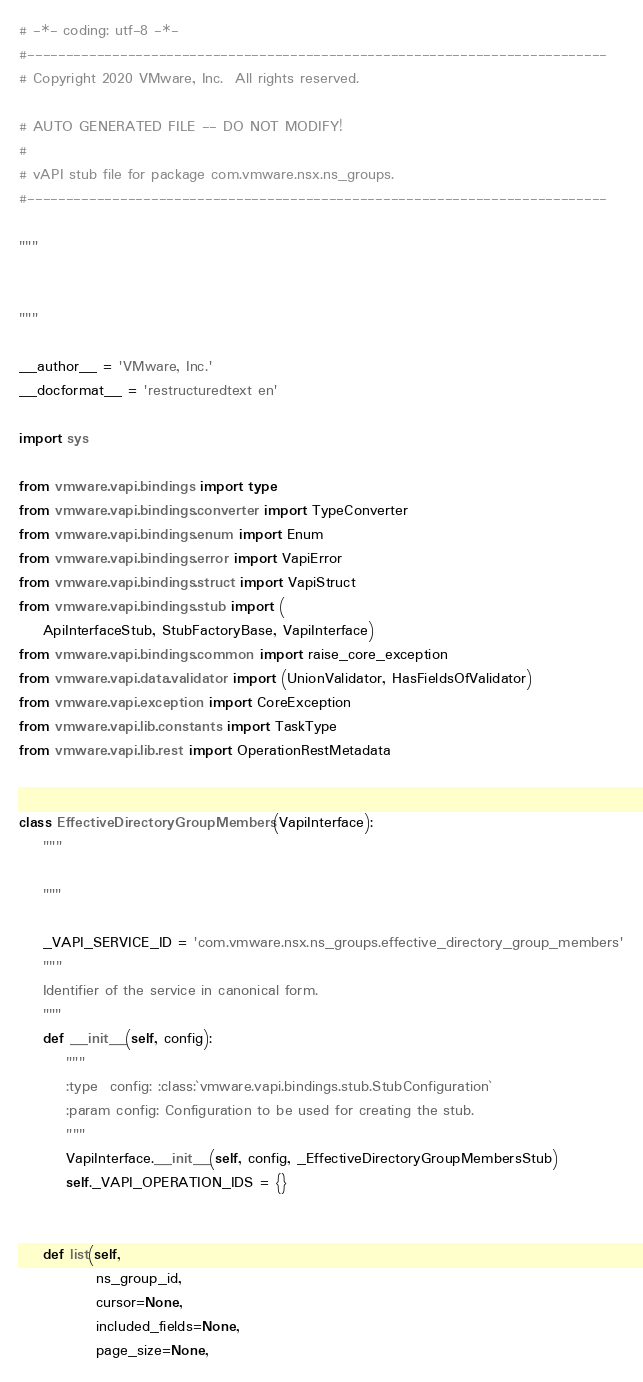<code> <loc_0><loc_0><loc_500><loc_500><_Python_># -*- coding: utf-8 -*-
#---------------------------------------------------------------------------
# Copyright 2020 VMware, Inc.  All rights reserved.

# AUTO GENERATED FILE -- DO NOT MODIFY!
#
# vAPI stub file for package com.vmware.nsx.ns_groups.
#---------------------------------------------------------------------------

"""


"""

__author__ = 'VMware, Inc.'
__docformat__ = 'restructuredtext en'

import sys

from vmware.vapi.bindings import type
from vmware.vapi.bindings.converter import TypeConverter
from vmware.vapi.bindings.enum import Enum
from vmware.vapi.bindings.error import VapiError
from vmware.vapi.bindings.struct import VapiStruct
from vmware.vapi.bindings.stub import (
    ApiInterfaceStub, StubFactoryBase, VapiInterface)
from vmware.vapi.bindings.common import raise_core_exception
from vmware.vapi.data.validator import (UnionValidator, HasFieldsOfValidator)
from vmware.vapi.exception import CoreException
from vmware.vapi.lib.constants import TaskType
from vmware.vapi.lib.rest import OperationRestMetadata


class EffectiveDirectoryGroupMembers(VapiInterface):
    """
    
    """

    _VAPI_SERVICE_ID = 'com.vmware.nsx.ns_groups.effective_directory_group_members'
    """
    Identifier of the service in canonical form.
    """
    def __init__(self, config):
        """
        :type  config: :class:`vmware.vapi.bindings.stub.StubConfiguration`
        :param config: Configuration to be used for creating the stub.
        """
        VapiInterface.__init__(self, config, _EffectiveDirectoryGroupMembersStub)
        self._VAPI_OPERATION_IDS = {}


    def list(self,
             ns_group_id,
             cursor=None,
             included_fields=None,
             page_size=None,</code> 